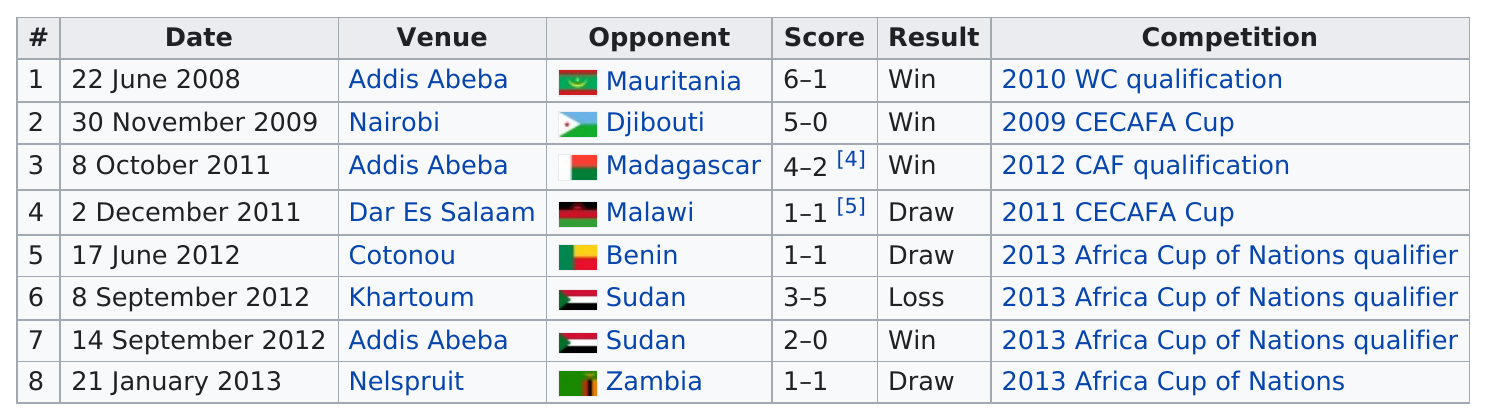Specify some key components in this picture. The overall scores of the two teams, Adis Abeba and Sudan, are 2-0 in favor of Adis Abeba. The table cloth has been in place for approximately 5 years. The Ethiopian national team has more wins than draws in comparison. For each winning game, the score was 6-1, 5-0, 4-2, and 2-0. The chart lists 7 different teams. 